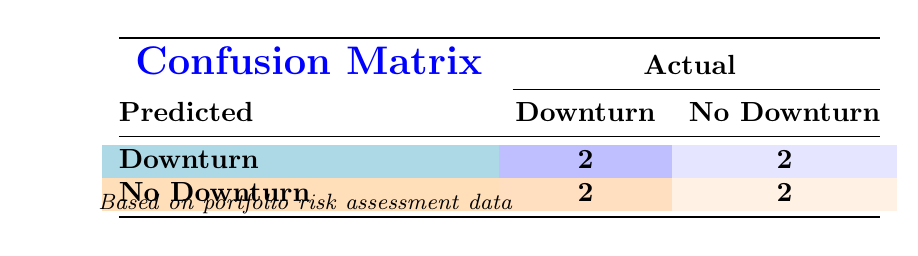What is the total number of companies that predicted a downturn? By inspecting the predicted downturn column, the entries marked as "Downturn" represent the companies that predicted a downturn. There are 4 companies: Apple Inc., Tesla Inc., Amazon.com Inc., and Walmart Inc.
Answer: 4 What is the number of correct predictions of downturns made? The correct predictions of downturns are represented in the table by the entries where both predicted and actual downturn are "True." There are 2 such cases: Apple Inc. and Amazon.com Inc.
Answer: 2 How many companies actually experienced a downturn? To find the number of companies that actually had a downturn, look for entries where actual downturn is marked as "True." This occurs for 4 companies: Apple Inc., Meta Platforms Inc., and Bank of America Corp.
Answer: 4 What is the predicted probability average for all companies predicting a downturn? First, we identify the predicted probabilities for companies with a "True" predicted downturn: Apple Inc. (0.85), Tesla Inc. (0.70), Amazon.com Inc. (0.75), and Walmart Inc. (0.65). Then, add these values (0.85 + 0.70 + 0.75 + 0.65 = 2.95) and divide by the number of companies (4): 2.95 / 4 = 0.7375
Answer: 0.7375 Is it true that more companies were incorrect in their downturn prediction than correct? To determine this, we check the confusion matrix for the counts of correct and incorrect predictions. There are 2 correct predictions (True/True) and 2 incorrect predictions (True/False), which indicates that the counts of correct and incorrect predictions are equal. Therefore, the statement is false.
Answer: No What is the ratio of companies that accurately predicted a downturn to the companies that did not predict a downturn correctly? There are 2 companies that accurately predicted a downturn and 2 companies that did not correctly predict a downturn (predicted downturn but no downturn). Therefore, the ratio is 2:2, which simplifies to 1:1.
Answer: 1:1 What is the impact average for companies that did experience a downturn? We look at the actual impact for companies in rows with actual downturn as "True": Apple Inc. (0.20), Meta Platforms Inc. (0.30), and Bank of America Corp. (0.25). Adding these values (0.20 + 0.30 + 0.25 = 0.75) and dividing by the number of companies (3) gives us an average of 0.75 / 3 = 0.25.
Answer: 0.25 How many companies had no downturn and did not predict a downturn? In the confusion matrix, look for entries with "No Downturn" for both predicted and actual. There are 2 such companies: Johnson & Johnson and Procter & Gamble Co.
Answer: 2 What percentage of companies predicted a downturn correctly? To find this percentage, first determine the number of correct predictions, which is 2. The total number of companies is 8. The percentage is calculated as (2 / 8) * 100 = 25%.
Answer: 25% 